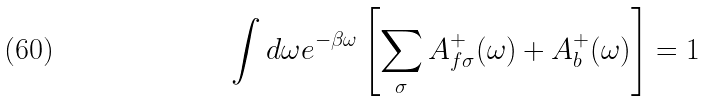<formula> <loc_0><loc_0><loc_500><loc_500>\int d \omega e ^ { - \beta \omega } \left [ \sum _ { \sigma } A _ { f \sigma } ^ { + } ( \omega ) + A _ { b } ^ { + } ( \omega ) \right ] = 1</formula> 